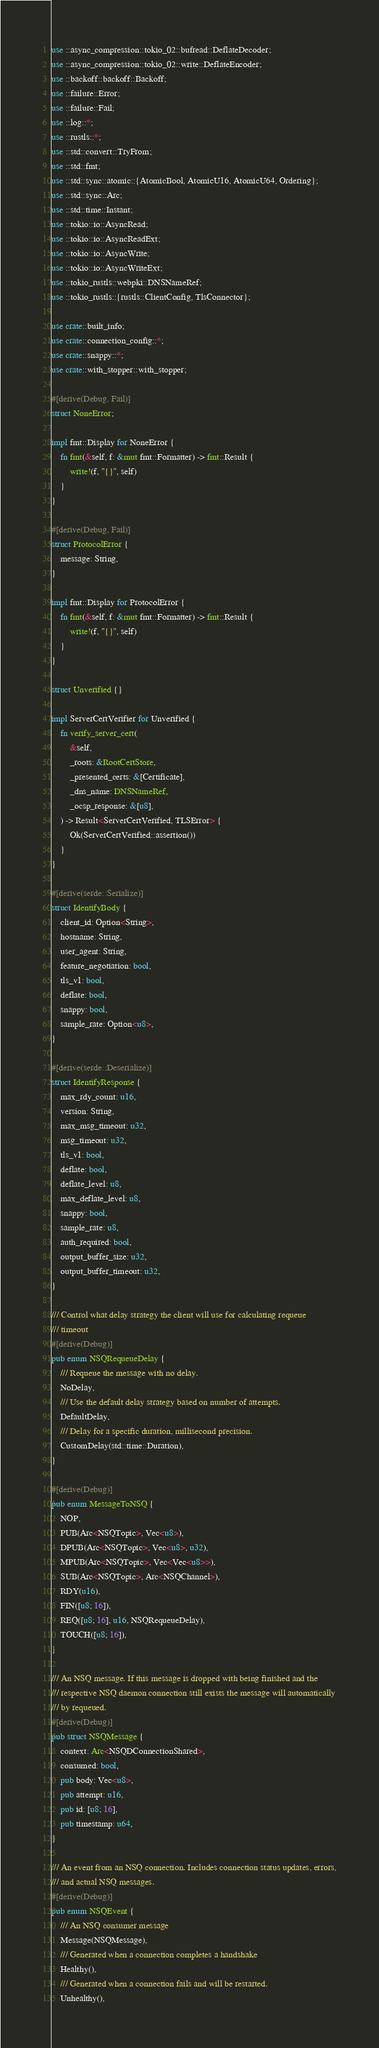<code> <loc_0><loc_0><loc_500><loc_500><_Rust_>use ::async_compression::tokio_02::bufread::DeflateDecoder;
use ::async_compression::tokio_02::write::DeflateEncoder;
use ::backoff::backoff::Backoff;
use ::failure::Error;
use ::failure::Fail;
use ::log::*;
use ::rustls::*;
use ::std::convert::TryFrom;
use ::std::fmt;
use ::std::sync::atomic::{AtomicBool, AtomicU16, AtomicU64, Ordering};
use ::std::sync::Arc;
use ::std::time::Instant;
use ::tokio::io::AsyncRead;
use ::tokio::io::AsyncReadExt;
use ::tokio::io::AsyncWrite;
use ::tokio::io::AsyncWriteExt;
use ::tokio_rustls::webpki::DNSNameRef;
use ::tokio_rustls::{rustls::ClientConfig, TlsConnector};

use crate::built_info;
use crate::connection_config::*;
use crate::snappy::*;
use crate::with_stopper::with_stopper;

#[derive(Debug, Fail)]
struct NoneError;

impl fmt::Display for NoneError {
    fn fmt(&self, f: &mut fmt::Formatter) -> fmt::Result {
        write!(f, "{}", self)
    }
}

#[derive(Debug, Fail)]
struct ProtocolError {
    message: String,
}

impl fmt::Display for ProtocolError {
    fn fmt(&self, f: &mut fmt::Formatter) -> fmt::Result {
        write!(f, "{}", self)
    }
}

struct Unverified {}

impl ServerCertVerifier for Unverified {
    fn verify_server_cert(
        &self,
        _roots: &RootCertStore,
        _presented_certs: &[Certificate],
        _dns_name: DNSNameRef,
        _ocsp_response: &[u8],
    ) -> Result<ServerCertVerified, TLSError> {
        Ok(ServerCertVerified::assertion())
    }
}

#[derive(serde::Serialize)]
struct IdentifyBody {
    client_id: Option<String>,
    hostname: String,
    user_agent: String,
    feature_negotiation: bool,
    tls_v1: bool,
    deflate: bool,
    snappy: bool,
    sample_rate: Option<u8>,
}

#[derive(serde::Deserialize)]
struct IdentifyResponse {
    max_rdy_count: u16,
    version: String,
    max_msg_timeout: u32,
    msg_timeout: u32,
    tls_v1: bool,
    deflate: bool,
    deflate_level: u8,
    max_deflate_level: u8,
    snappy: bool,
    sample_rate: u8,
    auth_required: bool,
    output_buffer_size: u32,
    output_buffer_timeout: u32,
}

/// Control what delay strategy the client will use for calculating requeue
/// timeout
#[derive(Debug)]
pub enum NSQRequeueDelay {
    /// Requeue the message with no delay.
    NoDelay,
    /// Use the default delay strategy based on number of attempts.
    DefaultDelay,
    /// Delay for a specific duration, millisecond precision.
    CustomDelay(std::time::Duration),
}

#[derive(Debug)]
pub enum MessageToNSQ {
    NOP,
    PUB(Arc<NSQTopic>, Vec<u8>),
    DPUB(Arc<NSQTopic>, Vec<u8>, u32),
    MPUB(Arc<NSQTopic>, Vec<Vec<u8>>),
    SUB(Arc<NSQTopic>, Arc<NSQChannel>),
    RDY(u16),
    FIN([u8; 16]),
    REQ([u8; 16], u16, NSQRequeueDelay),
    TOUCH([u8; 16]),
}

/// An NSQ message. If this message is dropped with being finished and the
/// respective NSQ daemon connection still exists the message will automatically
/// by requeued.
#[derive(Debug)]
pub struct NSQMessage {
    context: Arc<NSQDConnectionShared>,
    consumed: bool,
    pub body: Vec<u8>,
    pub attempt: u16,
    pub id: [u8; 16],
    pub timestamp: u64,
}

/// An event from an NSQ connection. Includes connection status updates, errors,
/// and actual NSQ messages.
#[derive(Debug)]
pub enum NSQEvent {
    /// An NSQ consumer message
    Message(NSQMessage),
    /// Generated when a connection completes a handshake
    Healthy(),
    /// Generated when a connection fails and will be restarted.
    Unhealthy(),</code> 